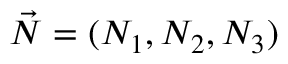Convert formula to latex. <formula><loc_0><loc_0><loc_500><loc_500>\vec { N } = ( N _ { 1 } , N _ { 2 } , N _ { 3 } )</formula> 